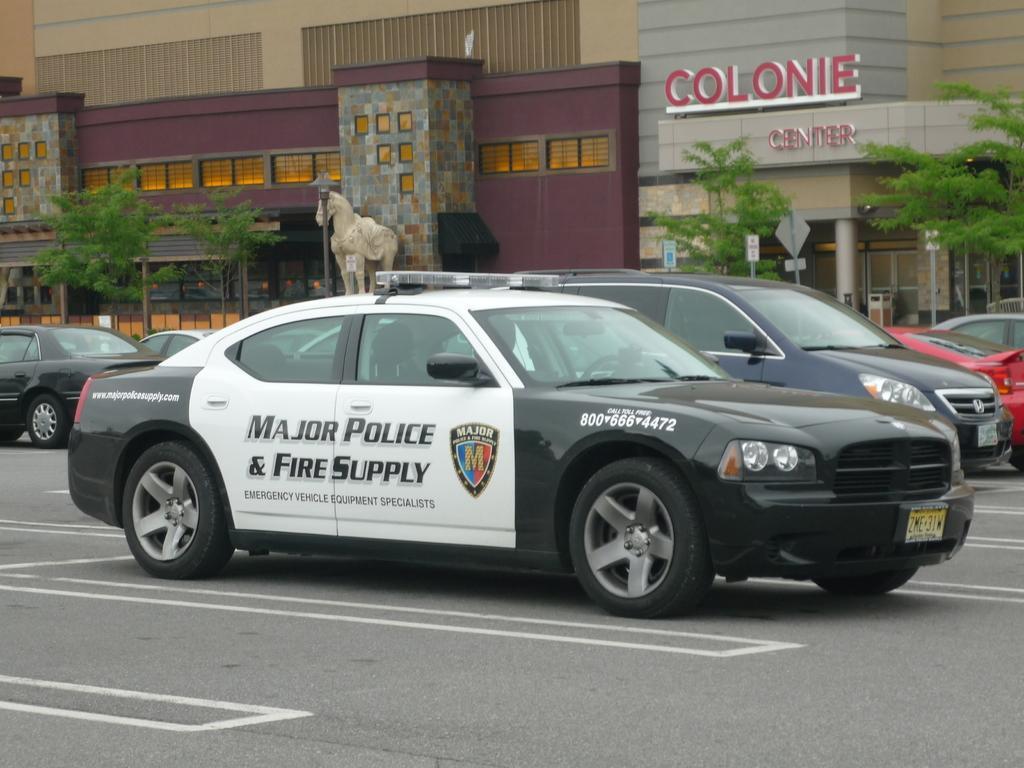Describe this image in one or two sentences. In this picture we can see some cars in the front, in the background there is a building, we can see some boards, trees and a statue in the middle. 